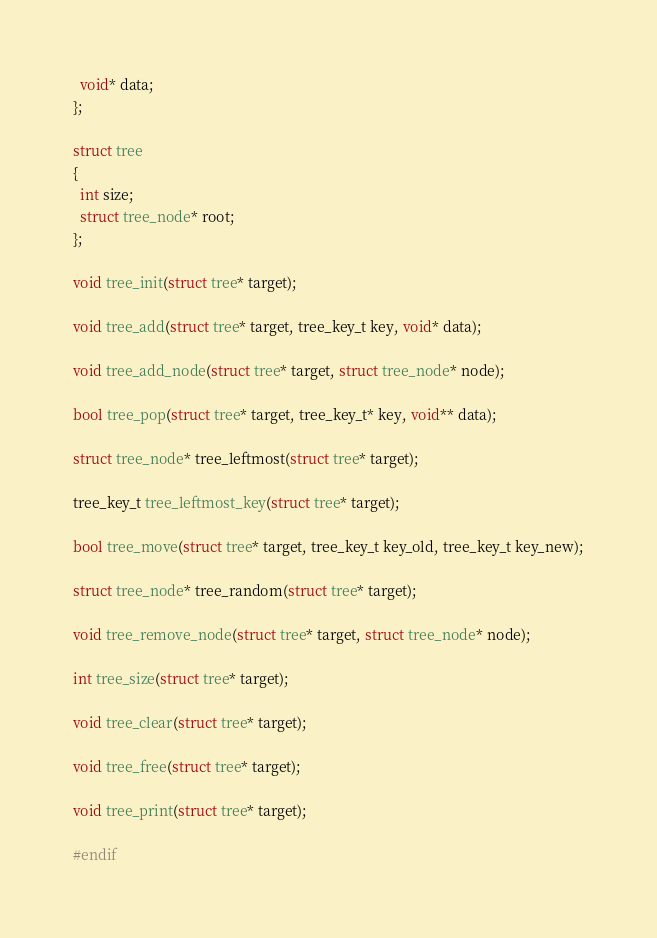<code> <loc_0><loc_0><loc_500><loc_500><_C_>  void* data;
};

struct tree
{
  int size;
  struct tree_node* root;
};

void tree_init(struct tree* target);

void tree_add(struct tree* target, tree_key_t key, void* data);

void tree_add_node(struct tree* target, struct tree_node* node);

bool tree_pop(struct tree* target, tree_key_t* key, void** data);

struct tree_node* tree_leftmost(struct tree* target);

tree_key_t tree_leftmost_key(struct tree* target);

bool tree_move(struct tree* target, tree_key_t key_old, tree_key_t key_new);

struct tree_node* tree_random(struct tree* target);

void tree_remove_node(struct tree* target, struct tree_node* node);

int tree_size(struct tree* target);

void tree_clear(struct tree* target);

void tree_free(struct tree* target);

void tree_print(struct tree* target);

#endif
</code> 